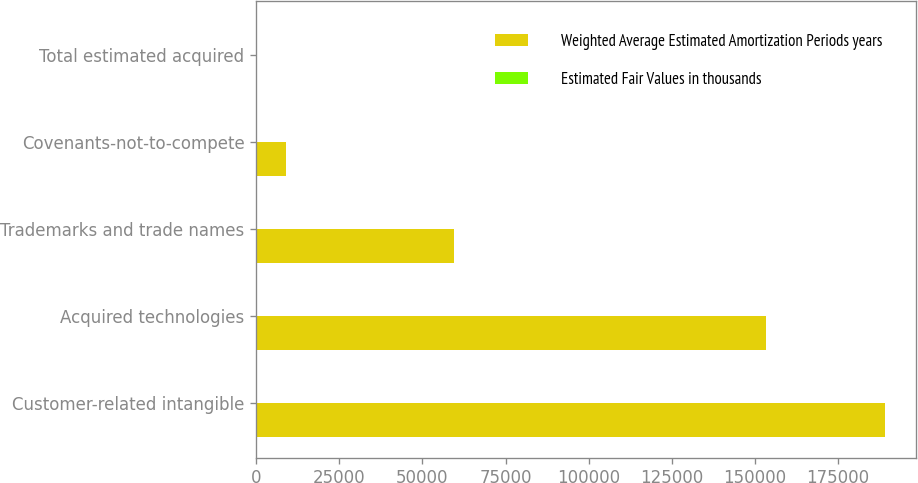Convert chart to OTSL. <chart><loc_0><loc_0><loc_500><loc_500><stacked_bar_chart><ecel><fcel>Customer-related intangible<fcel>Acquired technologies<fcel>Trademarks and trade names<fcel>Covenants-not-to-compete<fcel>Total estimated acquired<nl><fcel>Weighted Average Estimated Amortization Periods years<fcel>189000<fcel>153300<fcel>59400<fcel>8845<fcel>17<nl><fcel>Estimated Fair Values in thousands<fcel>17<fcel>9<fcel>15<fcel>3<fcel>13<nl></chart> 